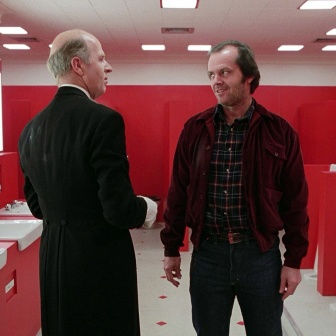Describe a realistic scenario for why these two men might be in this red bathroom. In a realistic scenario, the two men might be co-workers or old friends who unexpectedly ran into each other in the bathroom of a fancy restaurant or a corporate office. The man in the black suit could be sharing important work-related news or consulting the man in the red jacket about a problem he needs help with. Their body language and engagement suggest a meaningful conversation, perhaps about a major upcoming project, a corporate merger, or even personal matters. 